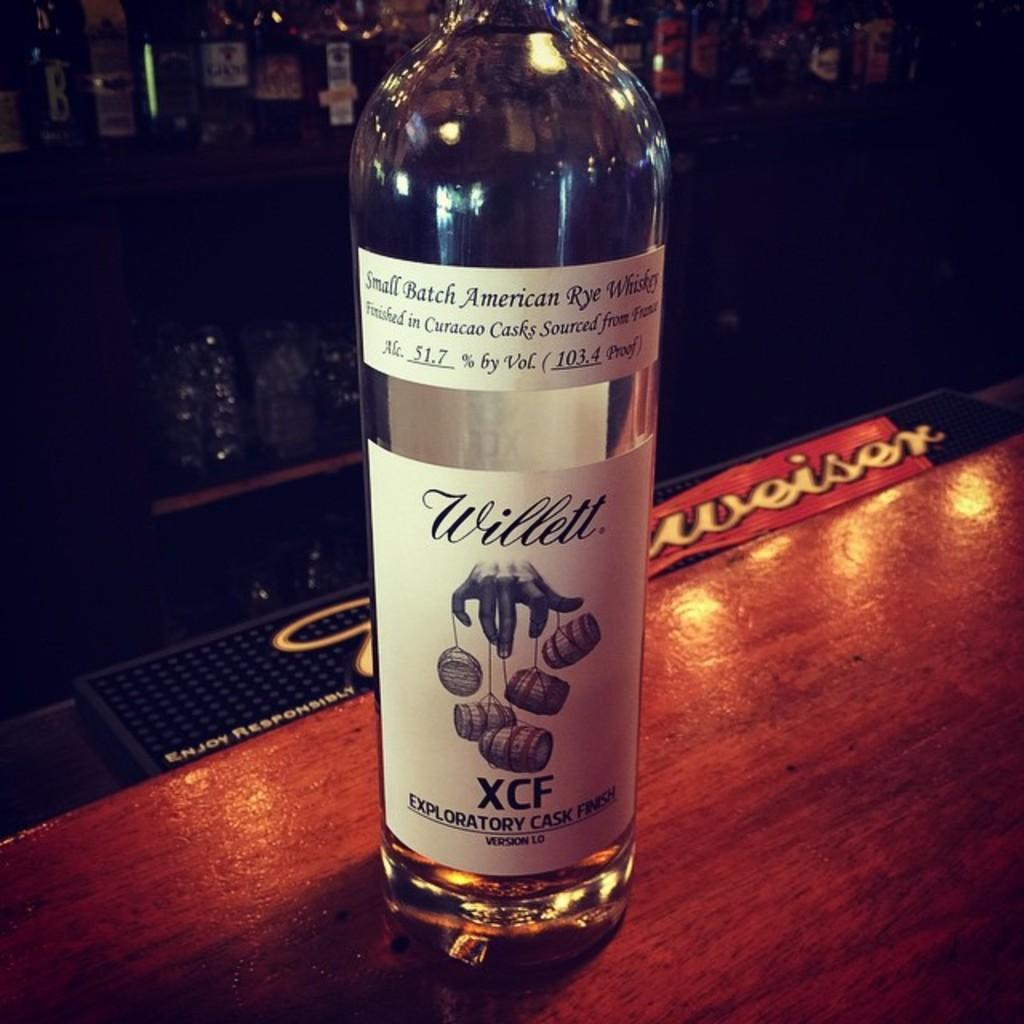<image>
Summarize the visual content of the image. A near empty bottle of Willet XCF whiskey on a wooden counter. 